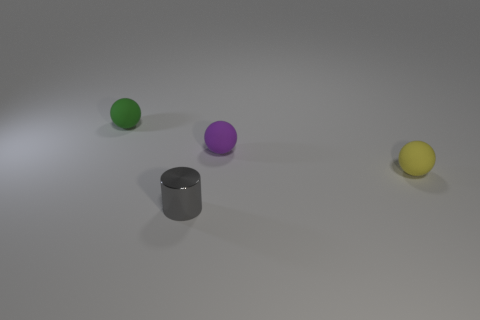Add 2 purple metal spheres. How many objects exist? 6 Subtract all balls. How many objects are left? 1 Subtract all small yellow balls. Subtract all large cyan matte cubes. How many objects are left? 3 Add 3 purple matte objects. How many purple matte objects are left? 4 Add 3 tiny blue shiny objects. How many tiny blue shiny objects exist? 3 Subtract 0 cyan balls. How many objects are left? 4 